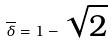<formula> <loc_0><loc_0><loc_500><loc_500>\overline { \delta } = 1 - \sqrt { 2 }</formula> 